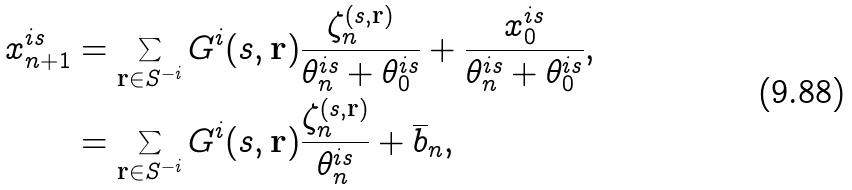<formula> <loc_0><loc_0><loc_500><loc_500>x _ { n + 1 } ^ { i s } & = \sum _ { \mathbf r \in S ^ { - i } } G ^ { i } ( s , \mathbf r ) \frac { \zeta _ { n } ^ { ( s , \mathbf r ) } } { \theta _ { n } ^ { i s } + \theta _ { 0 } ^ { i s } } + \frac { x _ { 0 } ^ { i s } } { \theta _ { n } ^ { i s } + \theta _ { 0 } ^ { i s } } , \\ & = \sum _ { \mathbf r \in S ^ { - i } } G ^ { i } ( s , \mathbf r ) \frac { \zeta _ { n } ^ { ( s , \mathbf r ) } } { \theta _ { n } ^ { i s } } + \overline { b } _ { n } ,</formula> 